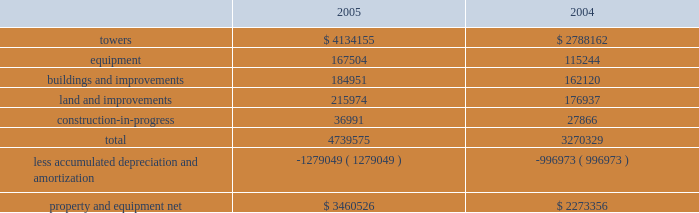American tower corporation and subsidiaries notes to consolidated financial statements 2014 ( continued ) operations , net , in the accompanying consolidated statements of operations for the year ended december 31 , 2003 .
( see note 9. ) other transactions 2014in august 2003 , the company consummated the sale of galaxy engineering ( galaxy ) , a radio frequency engineering , network design and tower-related consulting business ( previously included in the company 2019s network development services segment ) .
The purchase price of approximately $ 3.5 million included $ 2.0 million in cash , which the company received at closing , and an additional $ 1.5 million payable on january 15 , 2008 , or at an earlier date based on the future revenues of galaxy .
The company received $ 0.5 million of this amount in january 2005 .
Pursuant to this transaction , the company recorded a net loss on disposal of approximately $ 2.4 million in the accompanying consolidated statement of operations for the year ended december 31 , 2003 .
In may 2003 , the company consummated the sale of an office building in westwood , massachusetts ( previously held primarily as rental property and included in the company 2019s rental and management segment ) for a purchase price of approximately $ 18.5 million , including $ 2.4 million of cash proceeds and the buyer 2019s assumption of $ 16.1 million of related mortgage notes .
Pursuant to this transaction , the company recorded a net loss on disposal of approximately $ 3.6 million in the accompanying consolidated statement of operations for the year ended december 31 , 2003 .
In january 2003 , the company consummated the sale of flash technologies , its remaining components business ( previously included in the company 2019s network development services segment ) for approximately $ 35.5 million in cash and has recorded a net gain on disposal of approximately $ 0.1 million in the accompanying consolidated statement of operations for the year ended december 31 , 2003 .
In march 2003 , the company consummated the sale of an office building in schaumburg , illinois ( previously held primarily as rental property and included in the company 2019s rental and management segment ) for net proceeds of approximately $ 10.3 million in cash and recorded a net loss on disposal of $ 0.1 million in the accompanying consolidated statement of operations for the year ended december 31 , 2003 .
Property and equipment property and equipment ( including assets held under capital leases ) consist of the following as of december 31 , ( in thousands ) : .
Goodwill and other intangible assets the company 2019s net carrying amount of goodwill was approximately $ 2.1 billion as of december 312005 and $ 592.7 million as of december 31 , 2004 , all of which related to its rental and management segment .
The increase in the carrying value was as a result of the goodwill of $ 1.5 billion acquired in the merger with spectrasite , inc .
( see note 2. ) .
What is the the total depreciation and amortization expense in 2005? 
Computations: (1279049 - 996973)
Answer: 282076.0. 